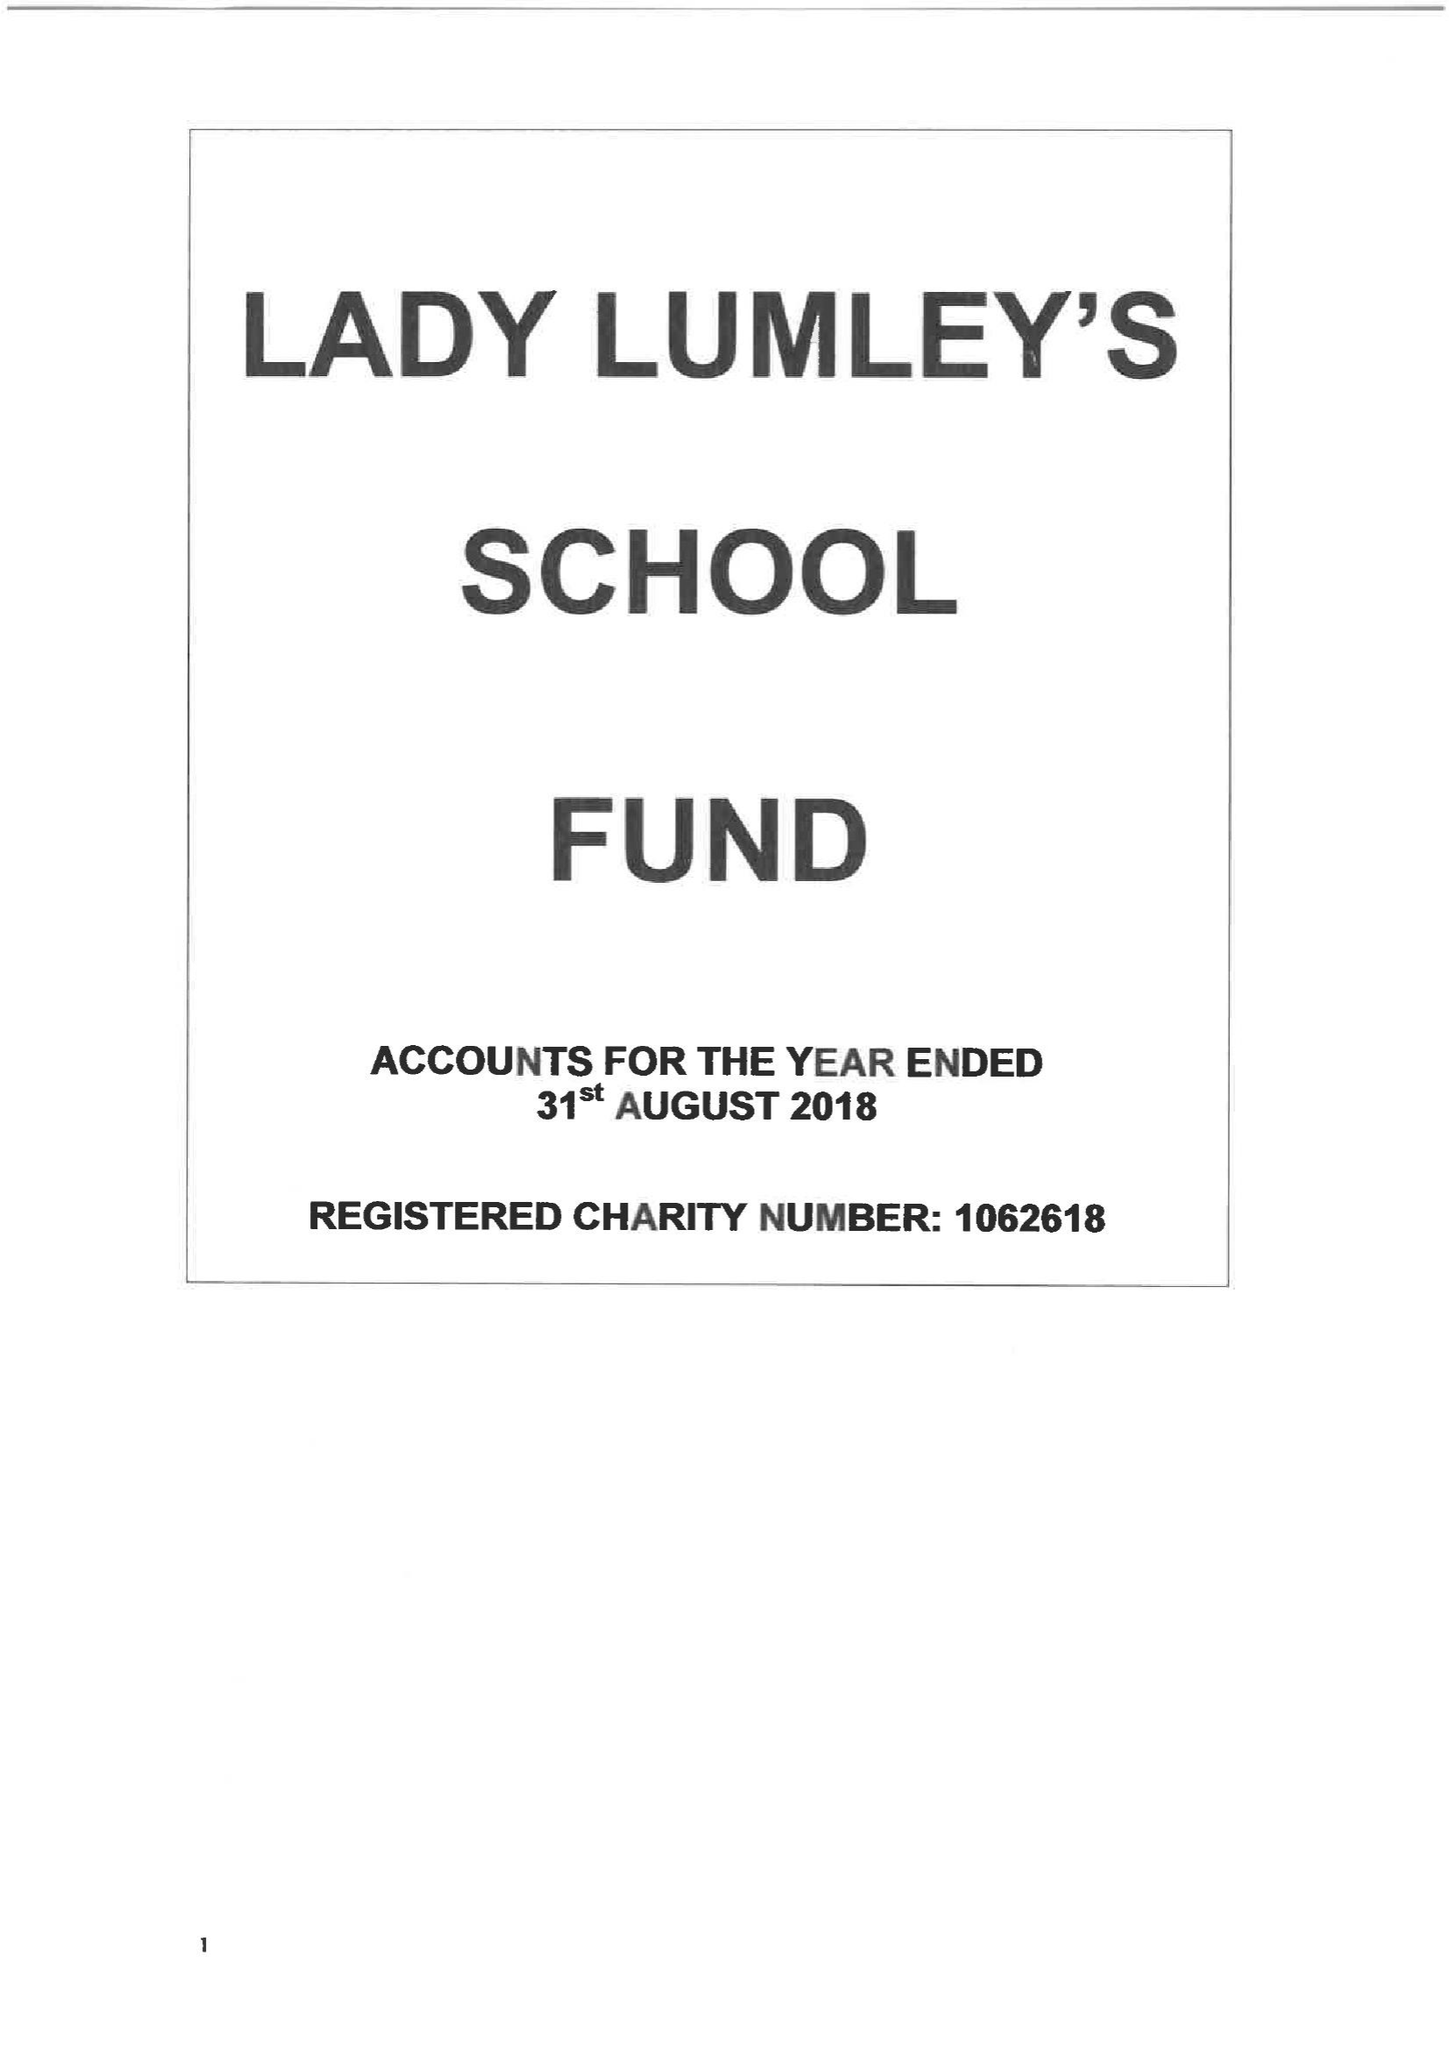What is the value for the report_date?
Answer the question using a single word or phrase. 2018-08-31 